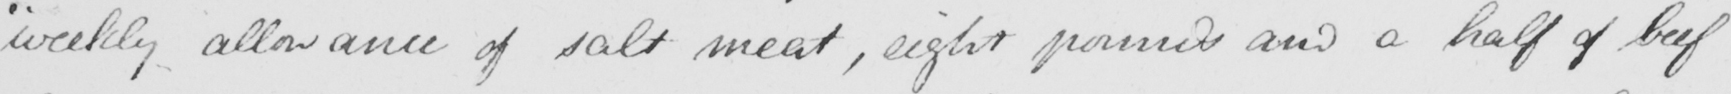Can you read and transcribe this handwriting? " weekly allowance of salt meat , eight pounds and a half of beef 